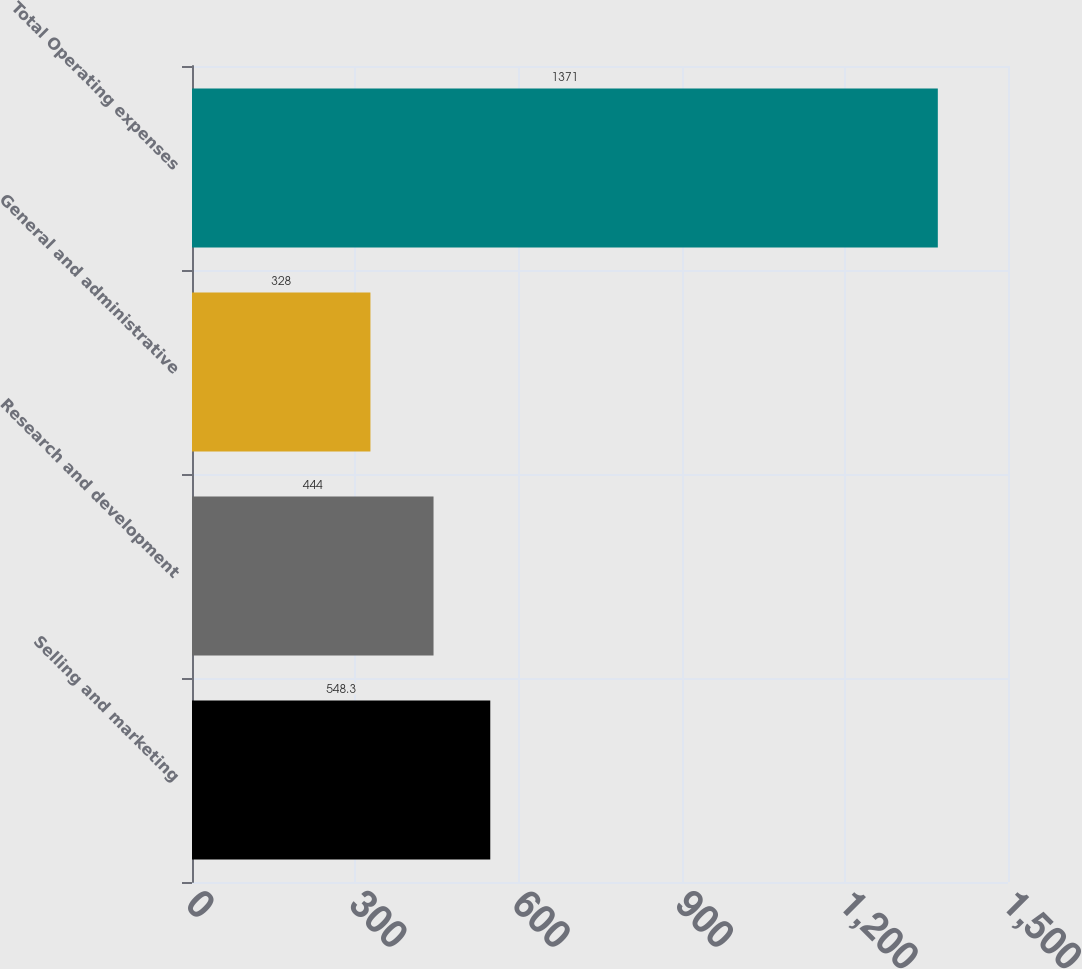Convert chart. <chart><loc_0><loc_0><loc_500><loc_500><bar_chart><fcel>Selling and marketing<fcel>Research and development<fcel>General and administrative<fcel>Total Operating expenses<nl><fcel>548.3<fcel>444<fcel>328<fcel>1371<nl></chart> 